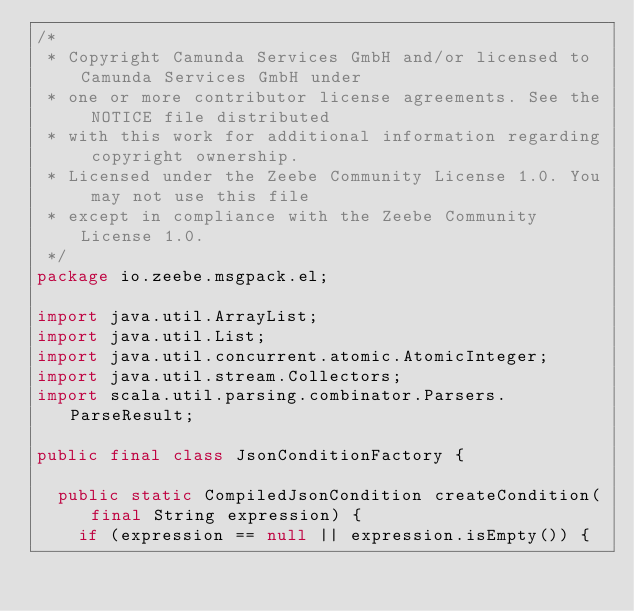Convert code to text. <code><loc_0><loc_0><loc_500><loc_500><_Java_>/*
 * Copyright Camunda Services GmbH and/or licensed to Camunda Services GmbH under
 * one or more contributor license agreements. See the NOTICE file distributed
 * with this work for additional information regarding copyright ownership.
 * Licensed under the Zeebe Community License 1.0. You may not use this file
 * except in compliance with the Zeebe Community License 1.0.
 */
package io.zeebe.msgpack.el;

import java.util.ArrayList;
import java.util.List;
import java.util.concurrent.atomic.AtomicInteger;
import java.util.stream.Collectors;
import scala.util.parsing.combinator.Parsers.ParseResult;

public final class JsonConditionFactory {

  public static CompiledJsonCondition createCondition(final String expression) {
    if (expression == null || expression.isEmpty()) {</code> 